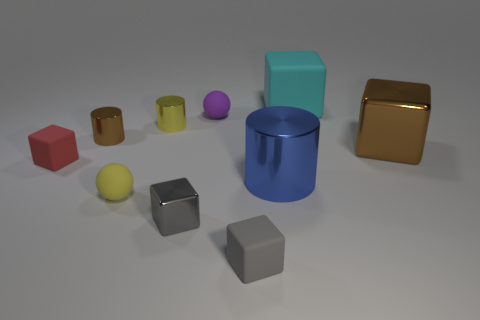There is a thing that is the same color as the big metal block; what size is it?
Your answer should be very brief. Small. The brown shiny thing that is the same shape as the yellow metal thing is what size?
Give a very brief answer. Small. Is there anything else that has the same material as the big cylinder?
Offer a terse response. Yes. What is the size of the rubber sphere that is in front of the cylinder that is to the right of the small gray matte object?
Your answer should be very brief. Small. Are there an equal number of tiny gray things that are behind the big blue thing and large gray matte blocks?
Offer a very short reply. Yes. How many other objects are the same color as the tiny shiny cube?
Ensure brevity in your answer.  1. Are there fewer tiny brown metal cylinders that are to the right of the small yellow sphere than small blue rubber spheres?
Provide a succinct answer. No. Is there another matte cube that has the same size as the red rubber block?
Make the answer very short. Yes. There is a big cylinder; is its color the same as the sphere that is right of the gray metallic cube?
Offer a terse response. No. What number of blue shiny cylinders are in front of the sphere in front of the blue cylinder?
Your answer should be compact. 0. 